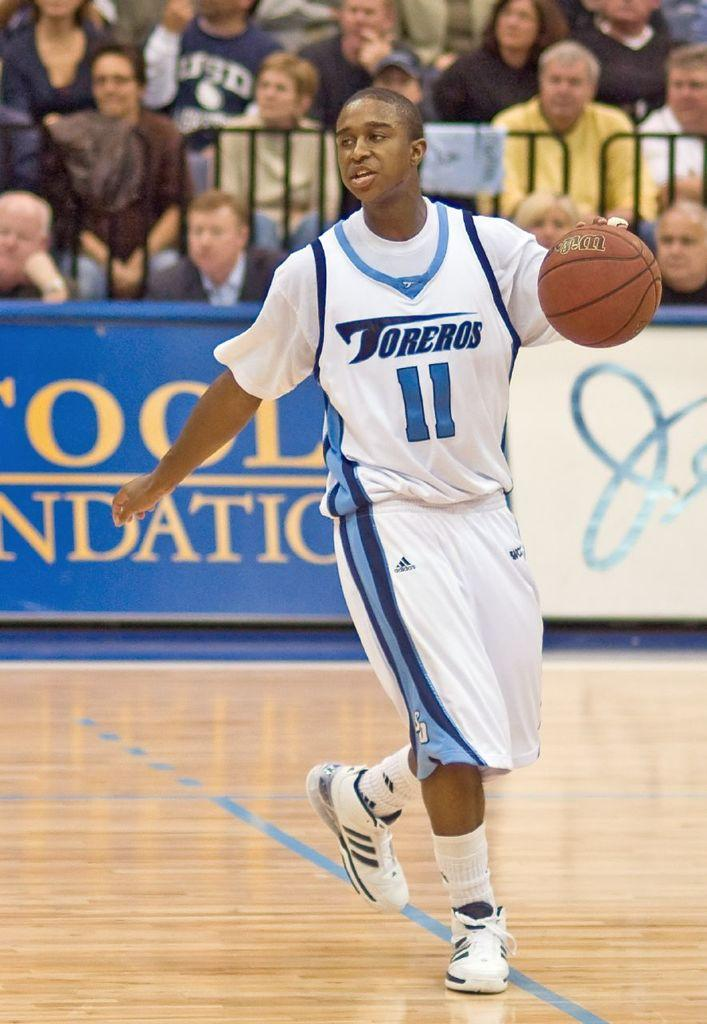<image>
Give a short and clear explanation of the subsequent image. Toreros basketball player 11 is dribbling the ball on the court. 